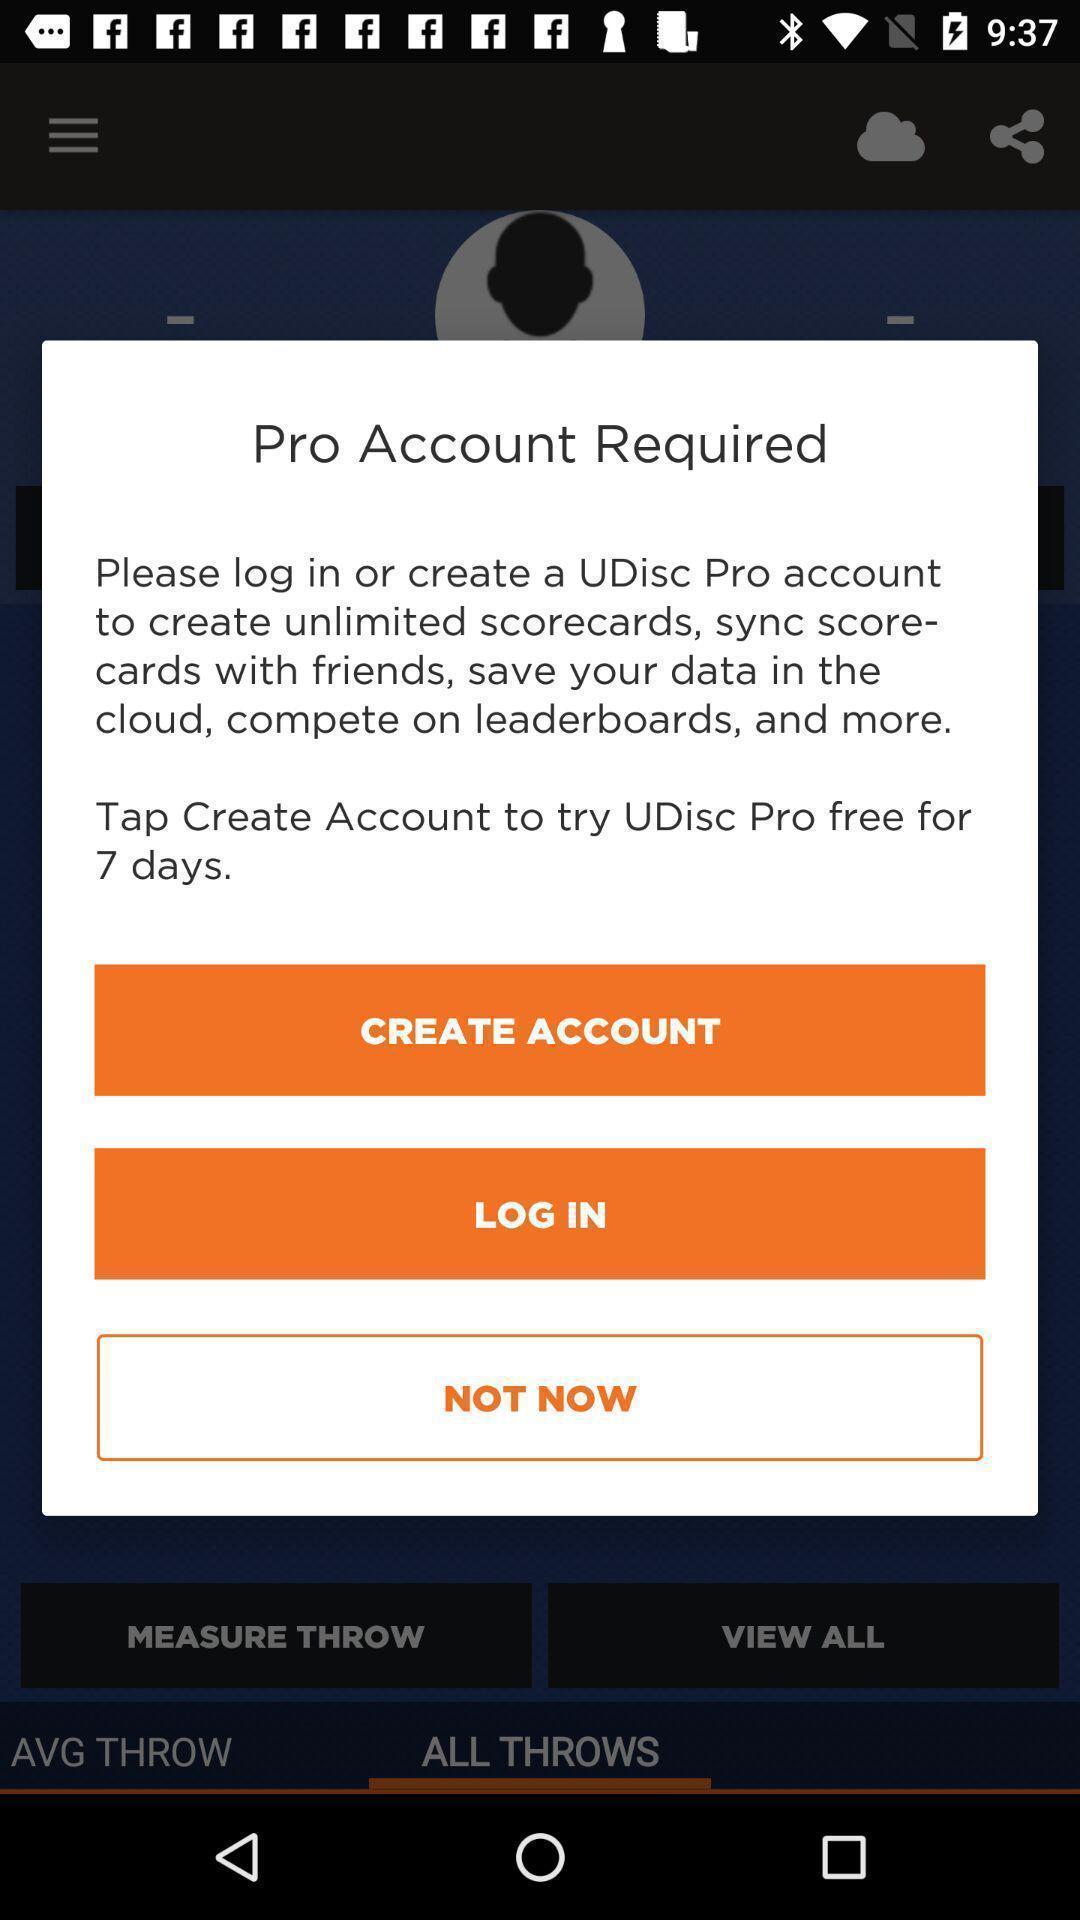Explain the elements present in this screenshot. Pop-up showing to create account. 